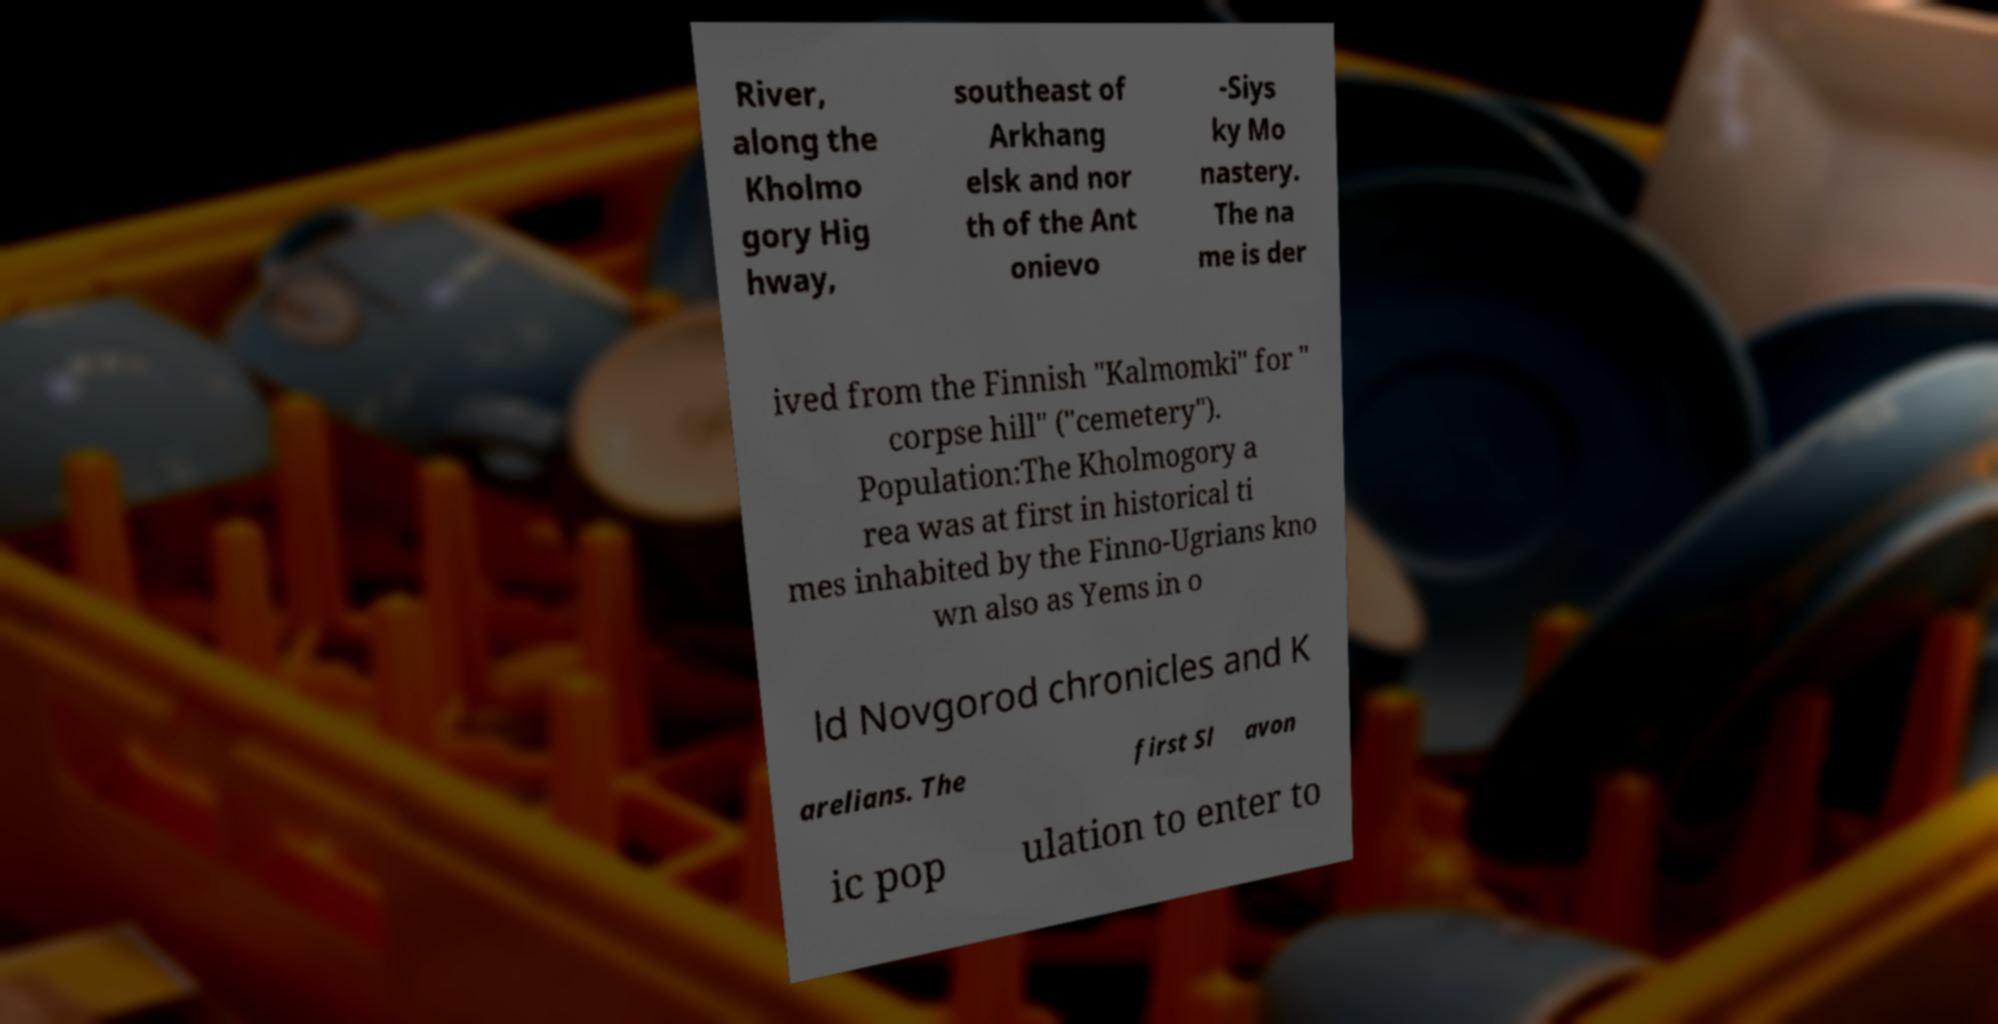Can you accurately transcribe the text from the provided image for me? River, along the Kholmo gory Hig hway, southeast of Arkhang elsk and nor th of the Ant onievo -Siys ky Mo nastery. The na me is der ived from the Finnish "Kalmomki" for " corpse hill" ("cemetery"). Population:The Kholmogory a rea was at first in historical ti mes inhabited by the Finno-Ugrians kno wn also as Yems in o ld Novgorod chronicles and K arelians. The first Sl avon ic pop ulation to enter to 